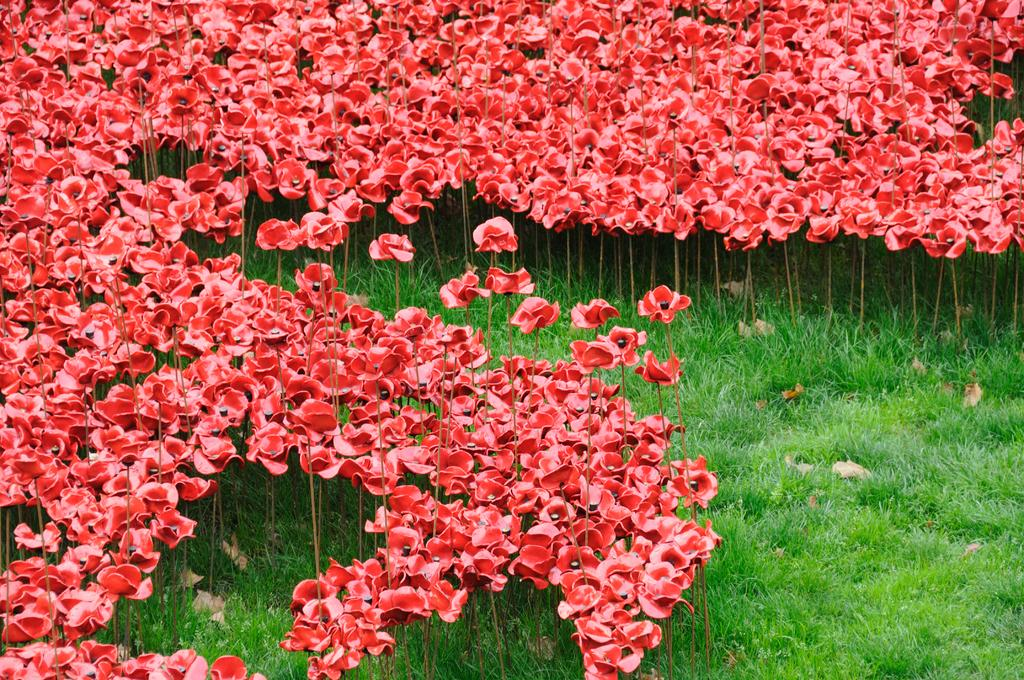What type of plants can be seen at the bottom of the image? There are plants with flowers at the bottom of the image. What is covering the ground at the bottom of the image? There is grass on the ground at the bottom of the image. What type of plants can be seen in the background of the image? There are plants with flowers in the background of the image. What is covering the ground in the background of the image? There is grass on the ground in the background of the image. What grade did the sponge receive on its recent behavior report? There is no sponge present in the image, and therefore no behavior report or grade can be associated with it. 